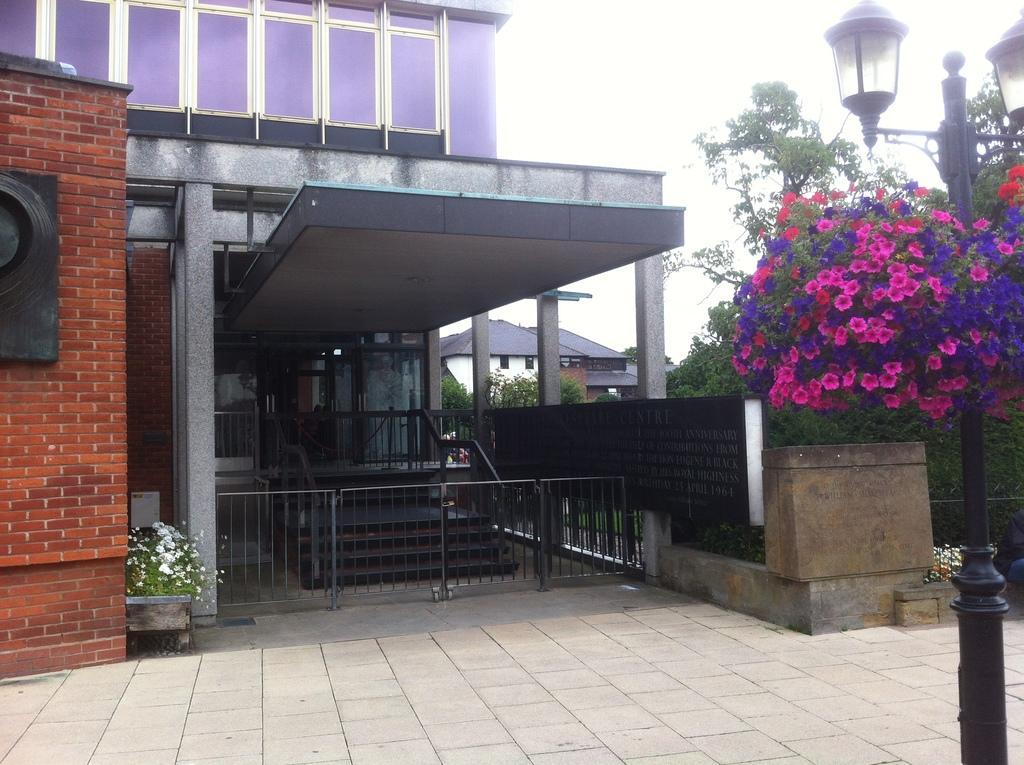Please provide a concise description of this image. In the center of the image there is a building. At the bottom there is a gate. On the right there is a pole. In the background there are trees and we can see flowers. There are sheds. At the top there is sky. 